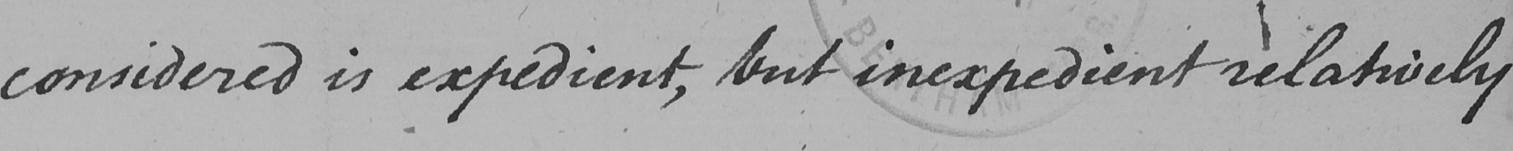Please transcribe the handwritten text in this image. considered is expedient , but inexpedient relatively 